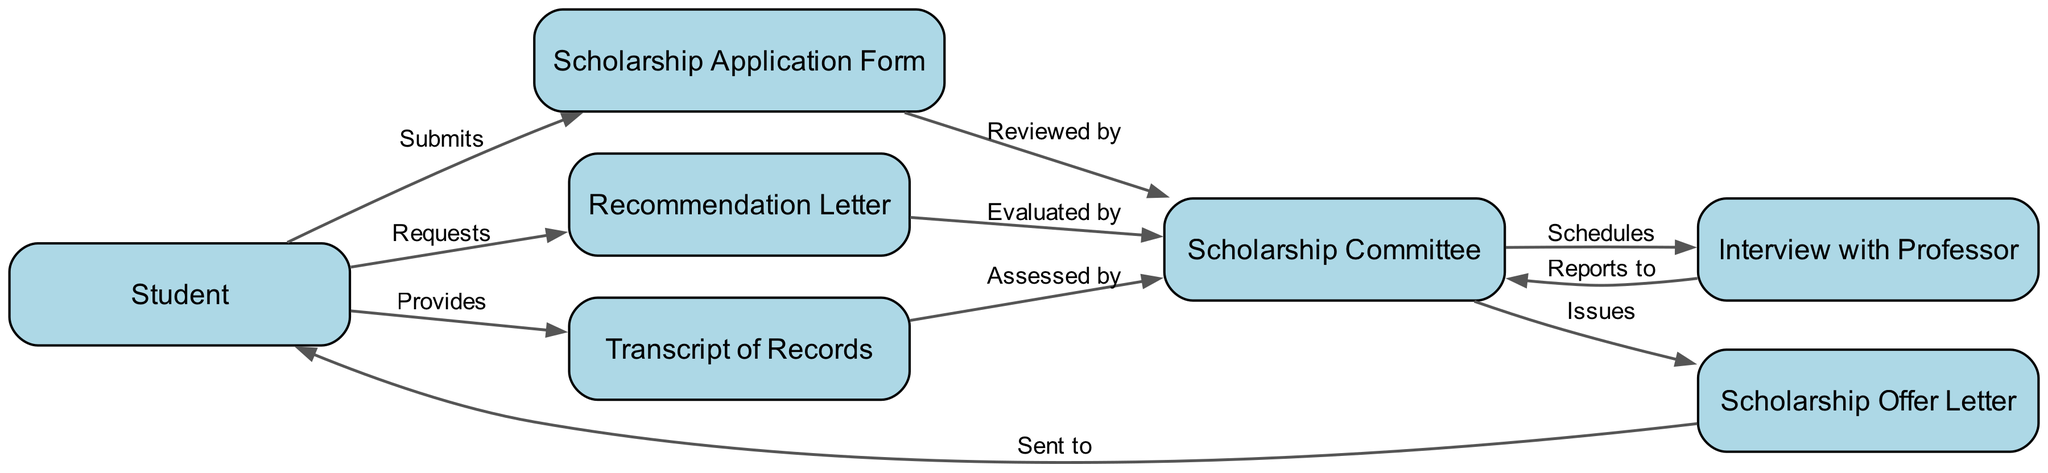What does the Student submit first in the process? The diagram shows that the first action the Student takes is submitting the Scholarship Application Form. This is indicated by the edge connecting the Student to the Scholarship Application Form with the label 'Submits'.
Answer: Scholarship Application Form How many documents does the Student provide? The diagram shows that the Student provides three documents: the Scholarship Application Form, Recommendation Letter, and Transcript of Records. Counting these, there are three distinct items represented.
Answer: 3 Which entity evaluates the Recommendation Letter? The arrow in the diagram points from the Recommendation Letter to the Scholarship Committee with the label 'Evaluated by'. This indicates that the evaluation of the Recommendation Letter is performed by the Scholarship Committee.
Answer: Scholarship Committee What does the Scholarship Committee issue at the end of the process? The diagram illustrates an edge going from the Scholarship Committee to the Scholarship Offer Letter labeled 'Issues', meaning the final action is issuing the Scholarship Offer Letter.
Answer: Scholarship Offer Letter What happens after the Student provides the Transcript of Records? Following the Student providing the Transcript of Records, there is an edge that leads to the Scholarship Committee indicating that the Transcript of Records is 'Assessed by' them. This means that the Scholarship Committee assesses the Transcript after it is provided.
Answer: Assessed by Scholarship Committee Who schedules the Interview with Professor? The diagram shows the direction from the Scholarship Committee to the Interview with Professor, labeled 'Schedules'. This indicates that the interview scheduling is performed by the Scholarship Committee.
Answer: Scholarship Committee How many interactions does the Scholarship Committee have with the Student? The diagram shows that the Scholarship Committee interacts with the Student in two ways, as depicted by the edges involving the Scholarship Offer Letter being 'Sent to' the Student and the initial documents being 'Reviewed by' them. This gives a total of two interactions.
Answer: 2 What does the Scholarship Committee do after assessing the documents? The edge from the Scholarship Committee to the Interview with Professor is labeled 'Schedules'. This indicates that after they assess the documents, the committee schedules the interview with the professor.
Answer: Schedules Interview with Professor 